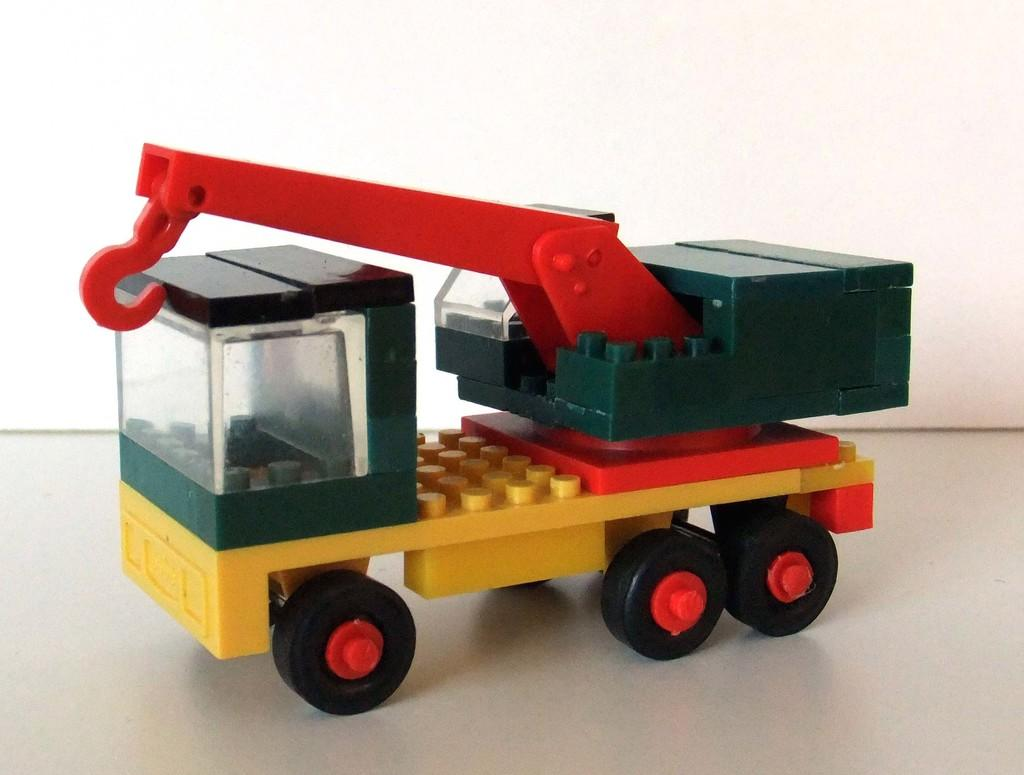What is the main subject of the image? The main subject of the image is a toy truck. Where is the toy truck located in the image? The toy truck is in the middle of the image. What can be seen in the background of the image? There is a wall in the background of the image. Is there a rabbit expressing regret in the image? There is no rabbit or any indication of regret present in the image. 